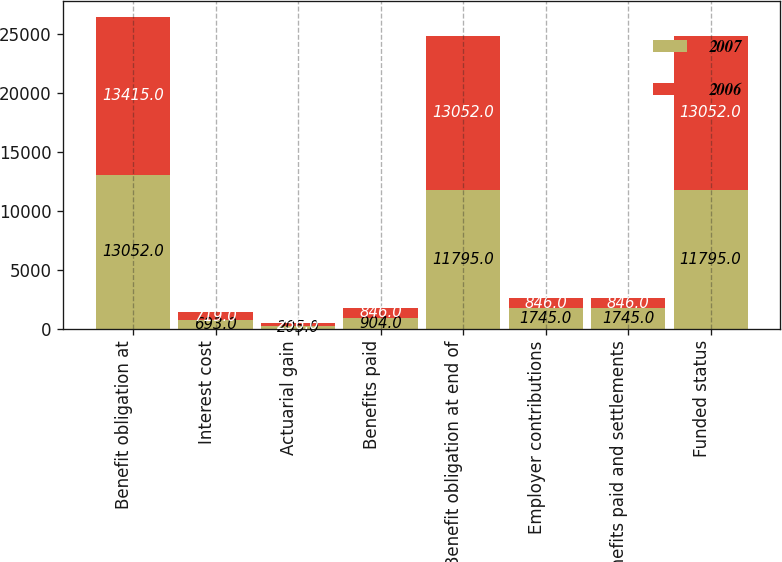Convert chart. <chart><loc_0><loc_0><loc_500><loc_500><stacked_bar_chart><ecel><fcel>Benefit obligation at<fcel>Interest cost<fcel>Actuarial gain<fcel>Benefits paid<fcel>Benefit obligation at end of<fcel>Employer contributions<fcel>Benefits paid and settlements<fcel>Funded status<nl><fcel>2007<fcel>13052<fcel>693<fcel>205<fcel>904<fcel>11795<fcel>1745<fcel>1745<fcel>11795<nl><fcel>2006<fcel>13415<fcel>719<fcel>236<fcel>846<fcel>13052<fcel>846<fcel>846<fcel>13052<nl></chart> 